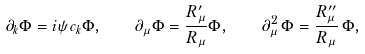Convert formula to latex. <formula><loc_0><loc_0><loc_500><loc_500>\partial _ { k } \Phi = i \psi c _ { k } \Phi , \quad \partial _ { \mu } \Phi = \frac { R _ { \mu } ^ { \prime } } { R _ { \mu } } \Phi , \quad \partial ^ { 2 } _ { \mu } \, \Phi = \frac { R _ { \mu } ^ { \prime \prime } } { R _ { \mu } } \, \Phi ,</formula> 